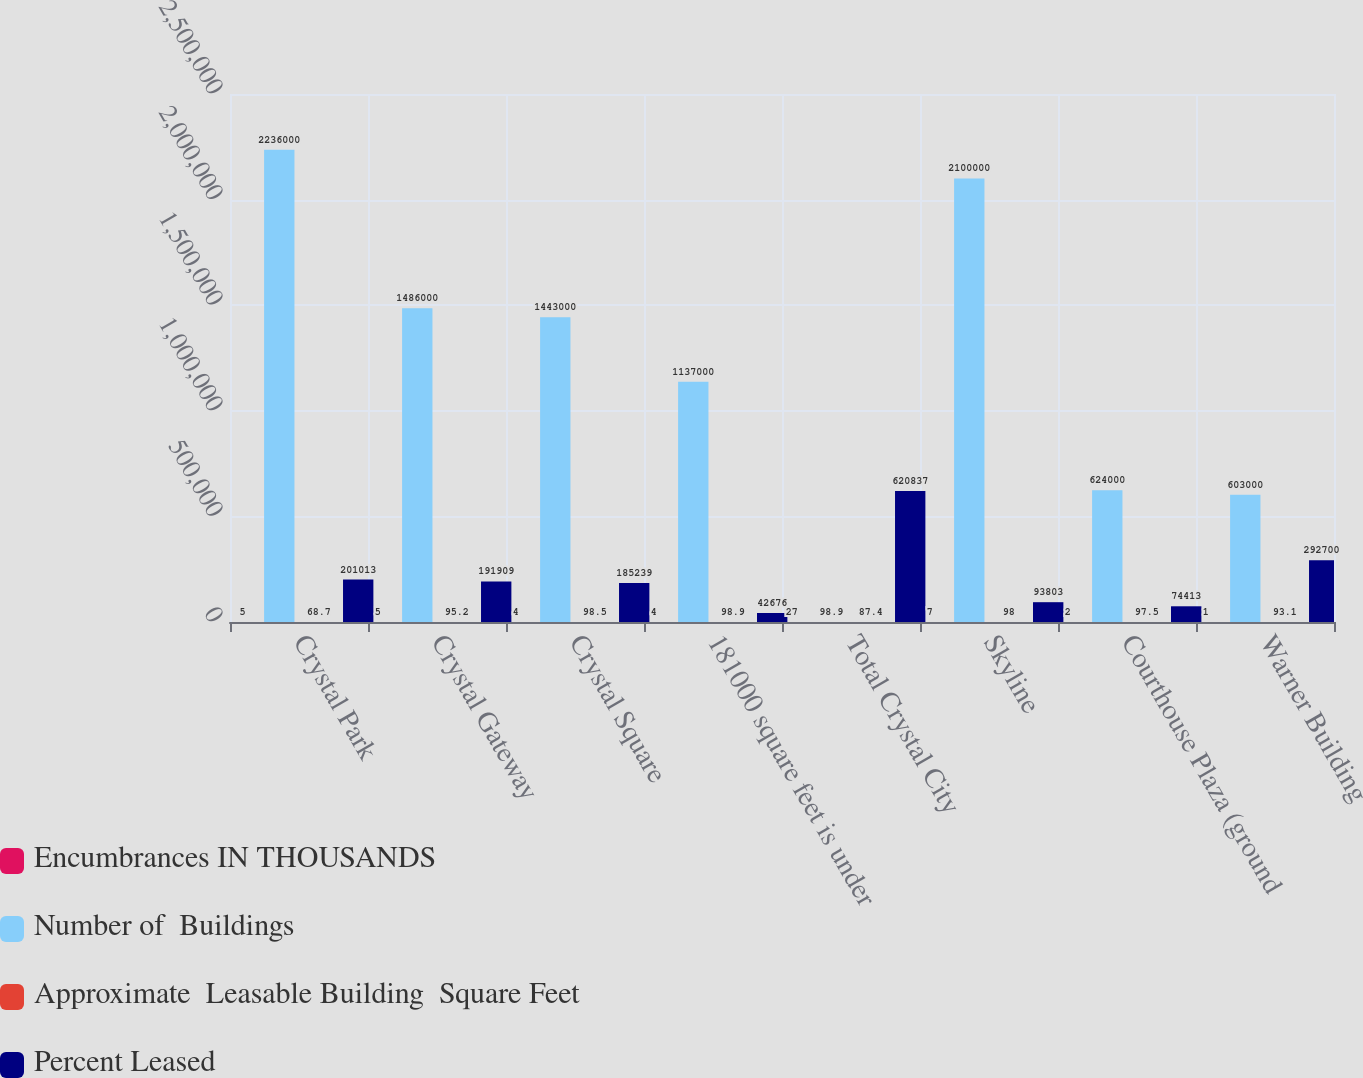Convert chart. <chart><loc_0><loc_0><loc_500><loc_500><stacked_bar_chart><ecel><fcel>Crystal Park<fcel>Crystal Gateway<fcel>Crystal Square<fcel>181000 square feet is under<fcel>Total Crystal City<fcel>Skyline<fcel>Courthouse Plaza (ground<fcel>Warner Building<nl><fcel>Encumbrances IN THOUSANDS<fcel>5<fcel>5<fcel>4<fcel>4<fcel>27<fcel>7<fcel>2<fcel>1<nl><fcel>Number of  Buildings<fcel>2.236e+06<fcel>1.486e+06<fcel>1.443e+06<fcel>1.137e+06<fcel>98.9<fcel>2.1e+06<fcel>624000<fcel>603000<nl><fcel>Approximate  Leasable Building  Square Feet<fcel>68.7<fcel>95.2<fcel>98.5<fcel>98.9<fcel>87.4<fcel>98<fcel>97.5<fcel>93.1<nl><fcel>Percent Leased<fcel>201013<fcel>191909<fcel>185239<fcel>42676<fcel>620837<fcel>93803<fcel>74413<fcel>292700<nl></chart> 